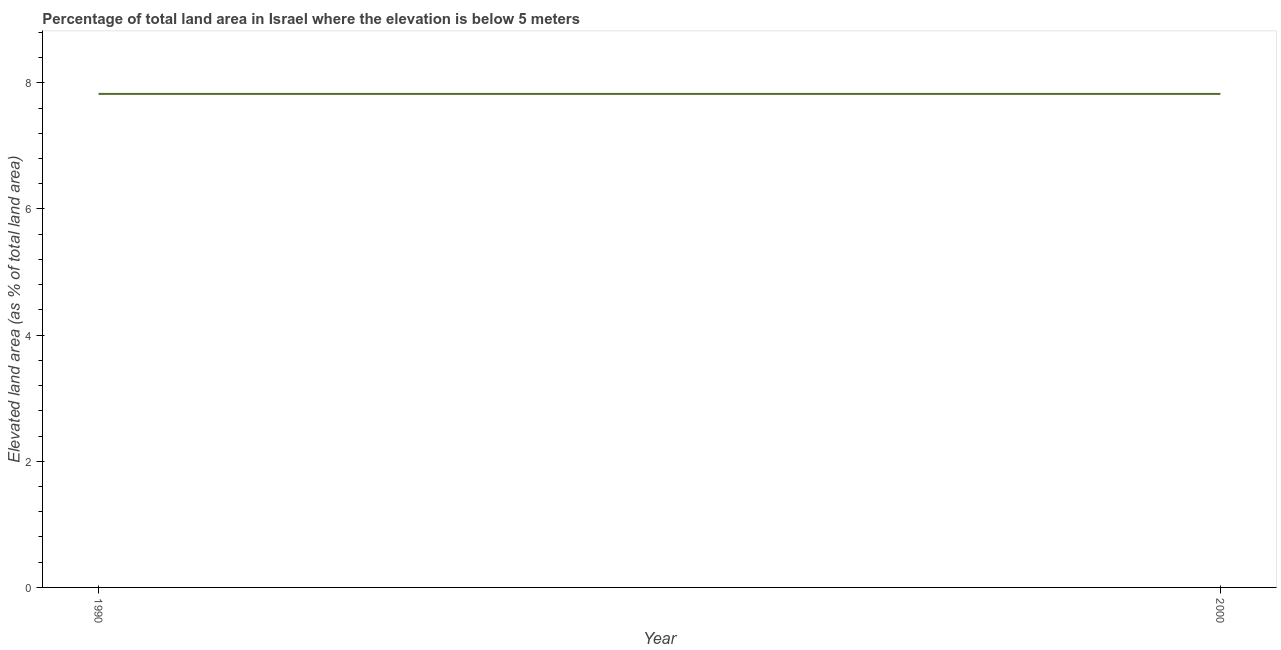What is the total elevated land area in 1990?
Your answer should be very brief. 7.82. Across all years, what is the maximum total elevated land area?
Your response must be concise. 7.82. Across all years, what is the minimum total elevated land area?
Make the answer very short. 7.82. What is the sum of the total elevated land area?
Offer a very short reply. 15.65. What is the average total elevated land area per year?
Your response must be concise. 7.82. What is the median total elevated land area?
Provide a short and direct response. 7.82. In how many years, is the total elevated land area greater than 1.6 %?
Your response must be concise. 2. Do a majority of the years between 1990 and 2000 (inclusive) have total elevated land area greater than 1.6 %?
Provide a short and direct response. Yes. Is the total elevated land area in 1990 less than that in 2000?
Keep it short and to the point. No. In how many years, is the total elevated land area greater than the average total elevated land area taken over all years?
Offer a very short reply. 0. Does the total elevated land area monotonically increase over the years?
Offer a very short reply. No. How many lines are there?
Make the answer very short. 1. How many years are there in the graph?
Your answer should be very brief. 2. Does the graph contain any zero values?
Offer a very short reply. No. Does the graph contain grids?
Your response must be concise. No. What is the title of the graph?
Keep it short and to the point. Percentage of total land area in Israel where the elevation is below 5 meters. What is the label or title of the Y-axis?
Ensure brevity in your answer.  Elevated land area (as % of total land area). What is the Elevated land area (as % of total land area) of 1990?
Provide a succinct answer. 7.82. What is the Elevated land area (as % of total land area) of 2000?
Give a very brief answer. 7.82. What is the difference between the Elevated land area (as % of total land area) in 1990 and 2000?
Offer a terse response. 0. What is the ratio of the Elevated land area (as % of total land area) in 1990 to that in 2000?
Your response must be concise. 1. 